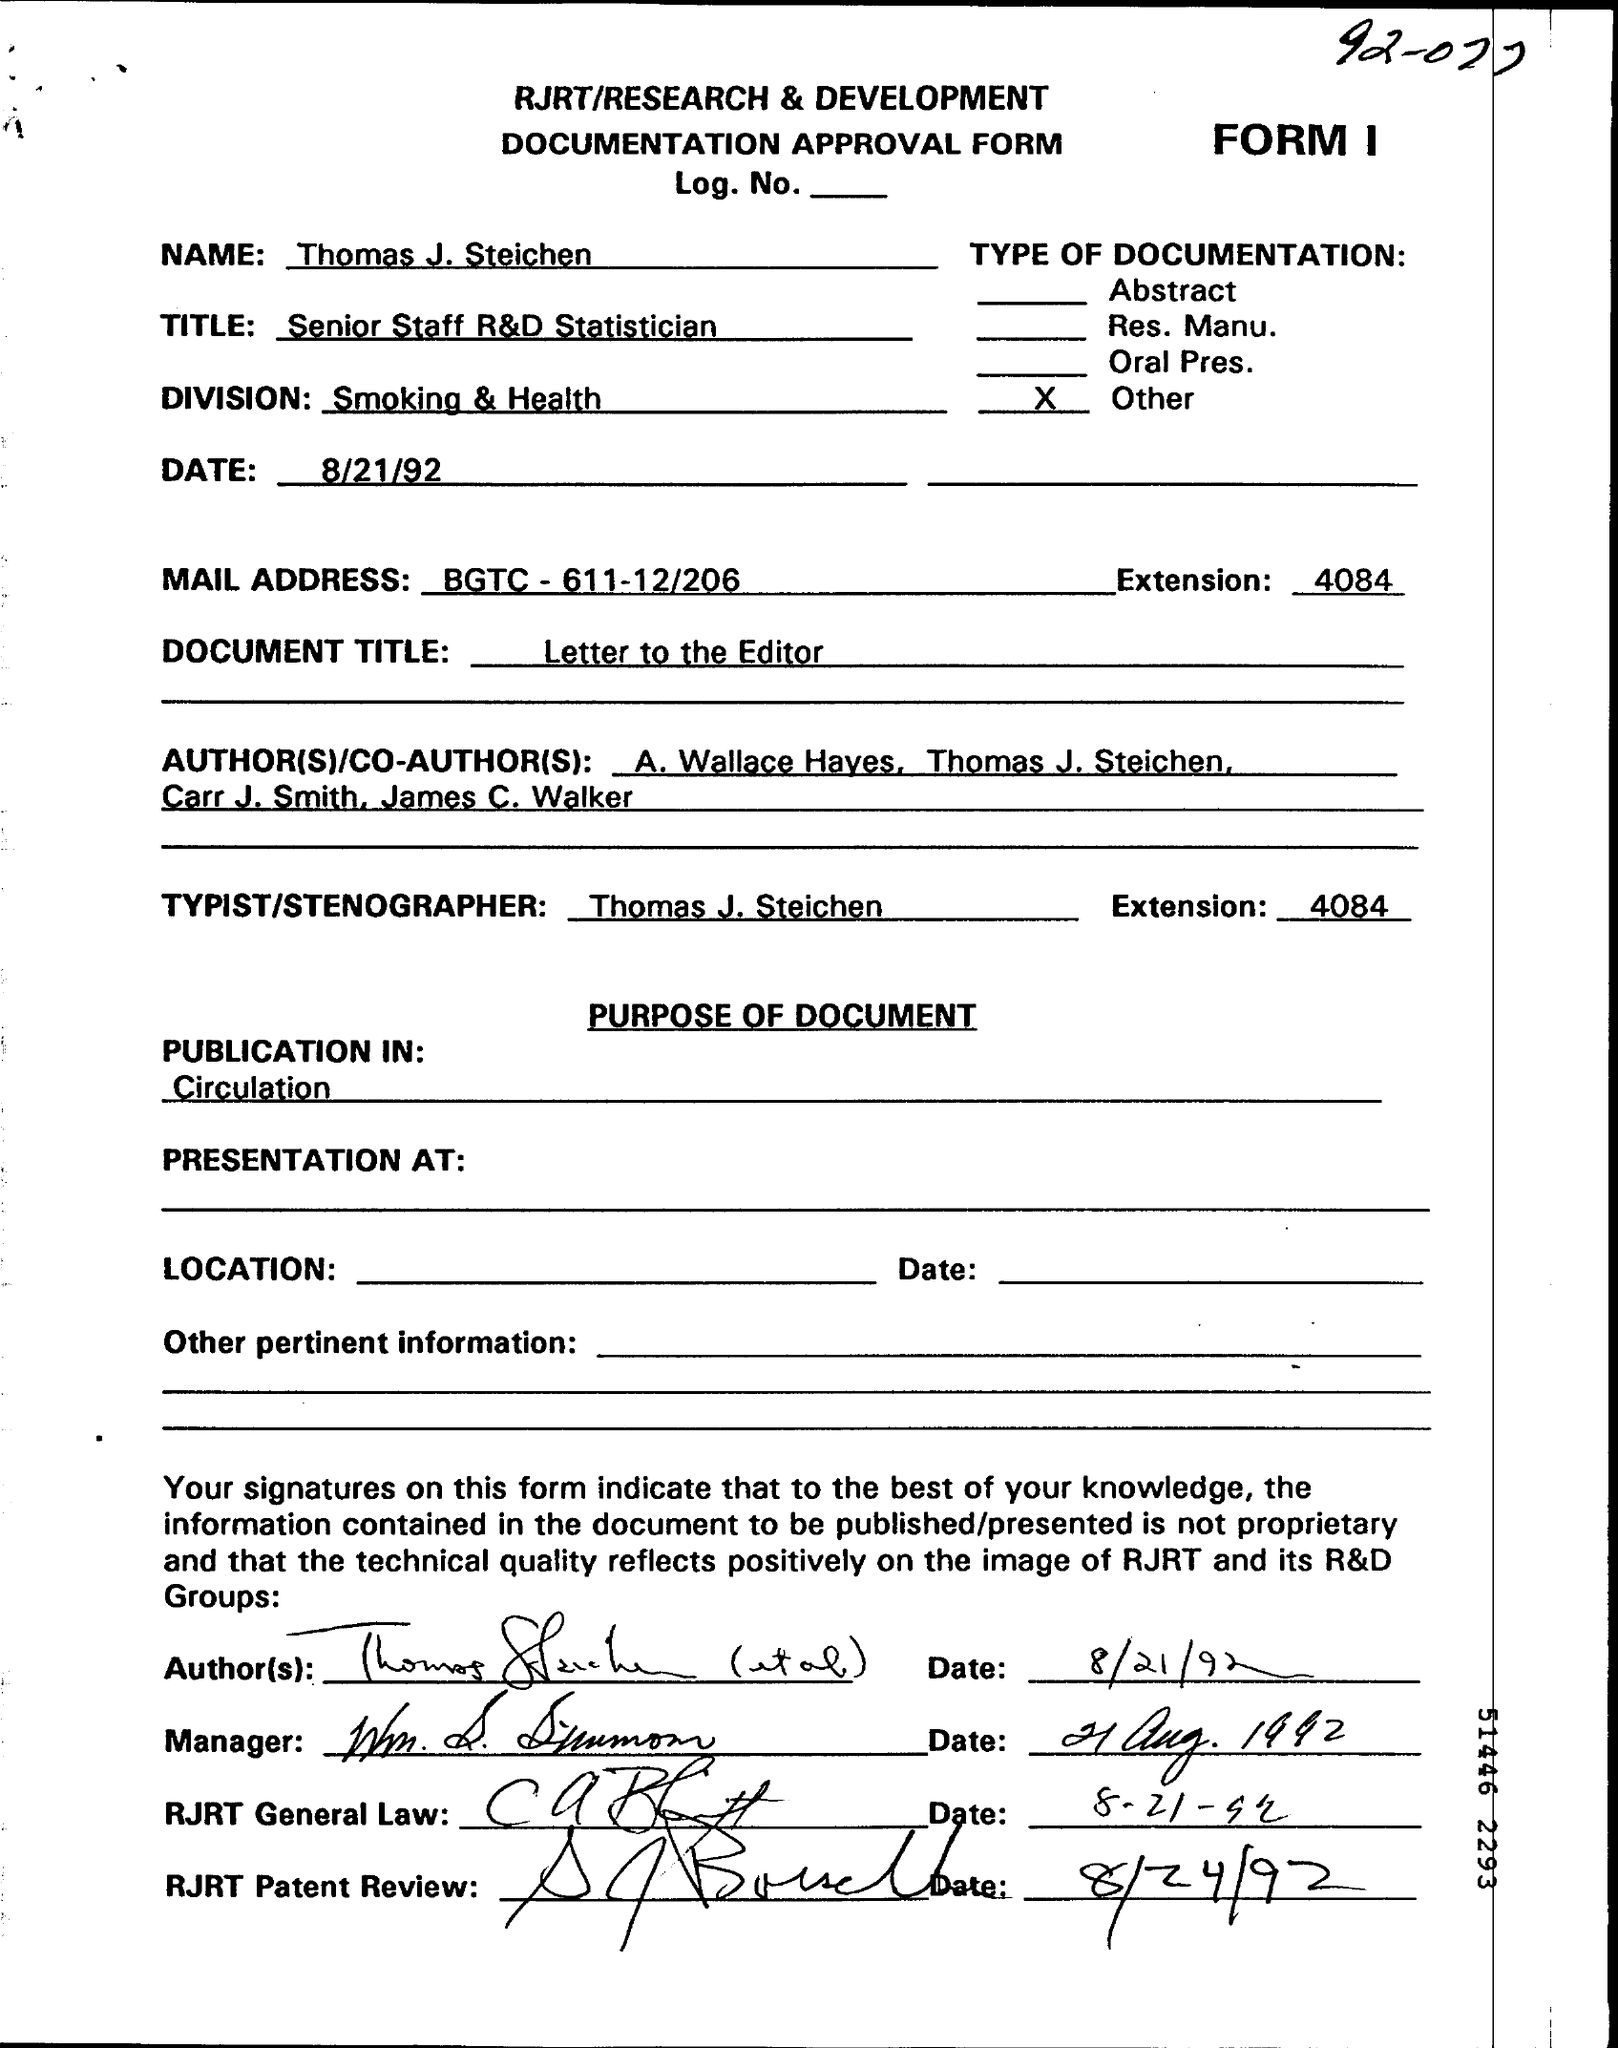What is the Name?
Give a very brief answer. Thomas J. Steichen. What is the Title?
Offer a very short reply. Senior Staff R&D Statistician. What is the Division?
Make the answer very short. Smoking & Health. What is the Date?
Your response must be concise. 8/21/92. What is the Extension?
Give a very brief answer. 4084. What is the Document Title?
Provide a succinct answer. Letter to the Editor. Who is the Typist/Stenographer?
Give a very brief answer. Thomas J. Steichen. 